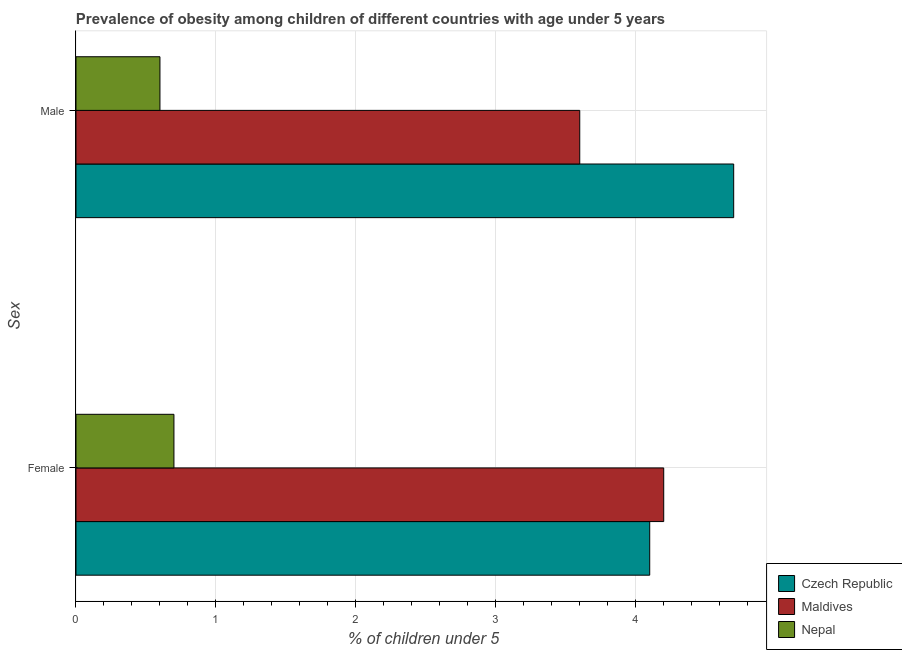Are the number of bars per tick equal to the number of legend labels?
Provide a succinct answer. Yes. How many bars are there on the 1st tick from the top?
Provide a succinct answer. 3. How many bars are there on the 1st tick from the bottom?
Offer a terse response. 3. What is the percentage of obese male children in Maldives?
Keep it short and to the point. 3.6. Across all countries, what is the maximum percentage of obese male children?
Provide a short and direct response. 4.7. Across all countries, what is the minimum percentage of obese male children?
Provide a short and direct response. 0.6. In which country was the percentage of obese male children maximum?
Keep it short and to the point. Czech Republic. In which country was the percentage of obese male children minimum?
Make the answer very short. Nepal. What is the total percentage of obese female children in the graph?
Give a very brief answer. 9. What is the difference between the percentage of obese female children in Maldives and that in Czech Republic?
Ensure brevity in your answer.  0.1. What is the difference between the percentage of obese male children in Nepal and the percentage of obese female children in Maldives?
Provide a short and direct response. -3.6. What is the average percentage of obese male children per country?
Offer a very short reply. 2.97. What is the difference between the percentage of obese male children and percentage of obese female children in Czech Republic?
Make the answer very short. 0.6. What is the ratio of the percentage of obese male children in Nepal to that in Maldives?
Give a very brief answer. 0.17. What does the 2nd bar from the top in Female represents?
Provide a short and direct response. Maldives. What does the 3rd bar from the bottom in Female represents?
Offer a terse response. Nepal. Are the values on the major ticks of X-axis written in scientific E-notation?
Keep it short and to the point. No. Does the graph contain any zero values?
Offer a terse response. No. Does the graph contain grids?
Keep it short and to the point. Yes. How many legend labels are there?
Give a very brief answer. 3. What is the title of the graph?
Your answer should be very brief. Prevalence of obesity among children of different countries with age under 5 years. What is the label or title of the X-axis?
Your answer should be very brief.  % of children under 5. What is the label or title of the Y-axis?
Offer a terse response. Sex. What is the  % of children under 5 of Czech Republic in Female?
Provide a succinct answer. 4.1. What is the  % of children under 5 of Maldives in Female?
Provide a short and direct response. 4.2. What is the  % of children under 5 in Nepal in Female?
Provide a succinct answer. 0.7. What is the  % of children under 5 in Czech Republic in Male?
Keep it short and to the point. 4.7. What is the  % of children under 5 of Maldives in Male?
Provide a short and direct response. 3.6. What is the  % of children under 5 of Nepal in Male?
Provide a succinct answer. 0.6. Across all Sex, what is the maximum  % of children under 5 of Czech Republic?
Make the answer very short. 4.7. Across all Sex, what is the maximum  % of children under 5 in Maldives?
Provide a short and direct response. 4.2. Across all Sex, what is the maximum  % of children under 5 in Nepal?
Offer a terse response. 0.7. Across all Sex, what is the minimum  % of children under 5 of Czech Republic?
Provide a short and direct response. 4.1. Across all Sex, what is the minimum  % of children under 5 of Maldives?
Your answer should be compact. 3.6. Across all Sex, what is the minimum  % of children under 5 in Nepal?
Keep it short and to the point. 0.6. What is the total  % of children under 5 of Czech Republic in the graph?
Ensure brevity in your answer.  8.8. What is the total  % of children under 5 in Nepal in the graph?
Offer a very short reply. 1.3. What is the difference between the  % of children under 5 in Czech Republic in Female and that in Male?
Give a very brief answer. -0.6. What is the difference between the  % of children under 5 in Maldives in Female and that in Male?
Make the answer very short. 0.6. What is the difference between the  % of children under 5 in Nepal in Female and that in Male?
Your answer should be compact. 0.1. What is the difference between the  % of children under 5 in Maldives in Female and the  % of children under 5 in Nepal in Male?
Provide a succinct answer. 3.6. What is the average  % of children under 5 of Nepal per Sex?
Your response must be concise. 0.65. What is the difference between the  % of children under 5 in Czech Republic and  % of children under 5 in Nepal in Female?
Provide a short and direct response. 3.4. What is the difference between the  % of children under 5 of Maldives and  % of children under 5 of Nepal in Female?
Make the answer very short. 3.5. What is the difference between the  % of children under 5 in Czech Republic and  % of children under 5 in Maldives in Male?
Provide a succinct answer. 1.1. What is the ratio of the  % of children under 5 of Czech Republic in Female to that in Male?
Ensure brevity in your answer.  0.87. What is the difference between the highest and the second highest  % of children under 5 in Czech Republic?
Your answer should be compact. 0.6. What is the difference between the highest and the lowest  % of children under 5 of Czech Republic?
Your answer should be compact. 0.6. 